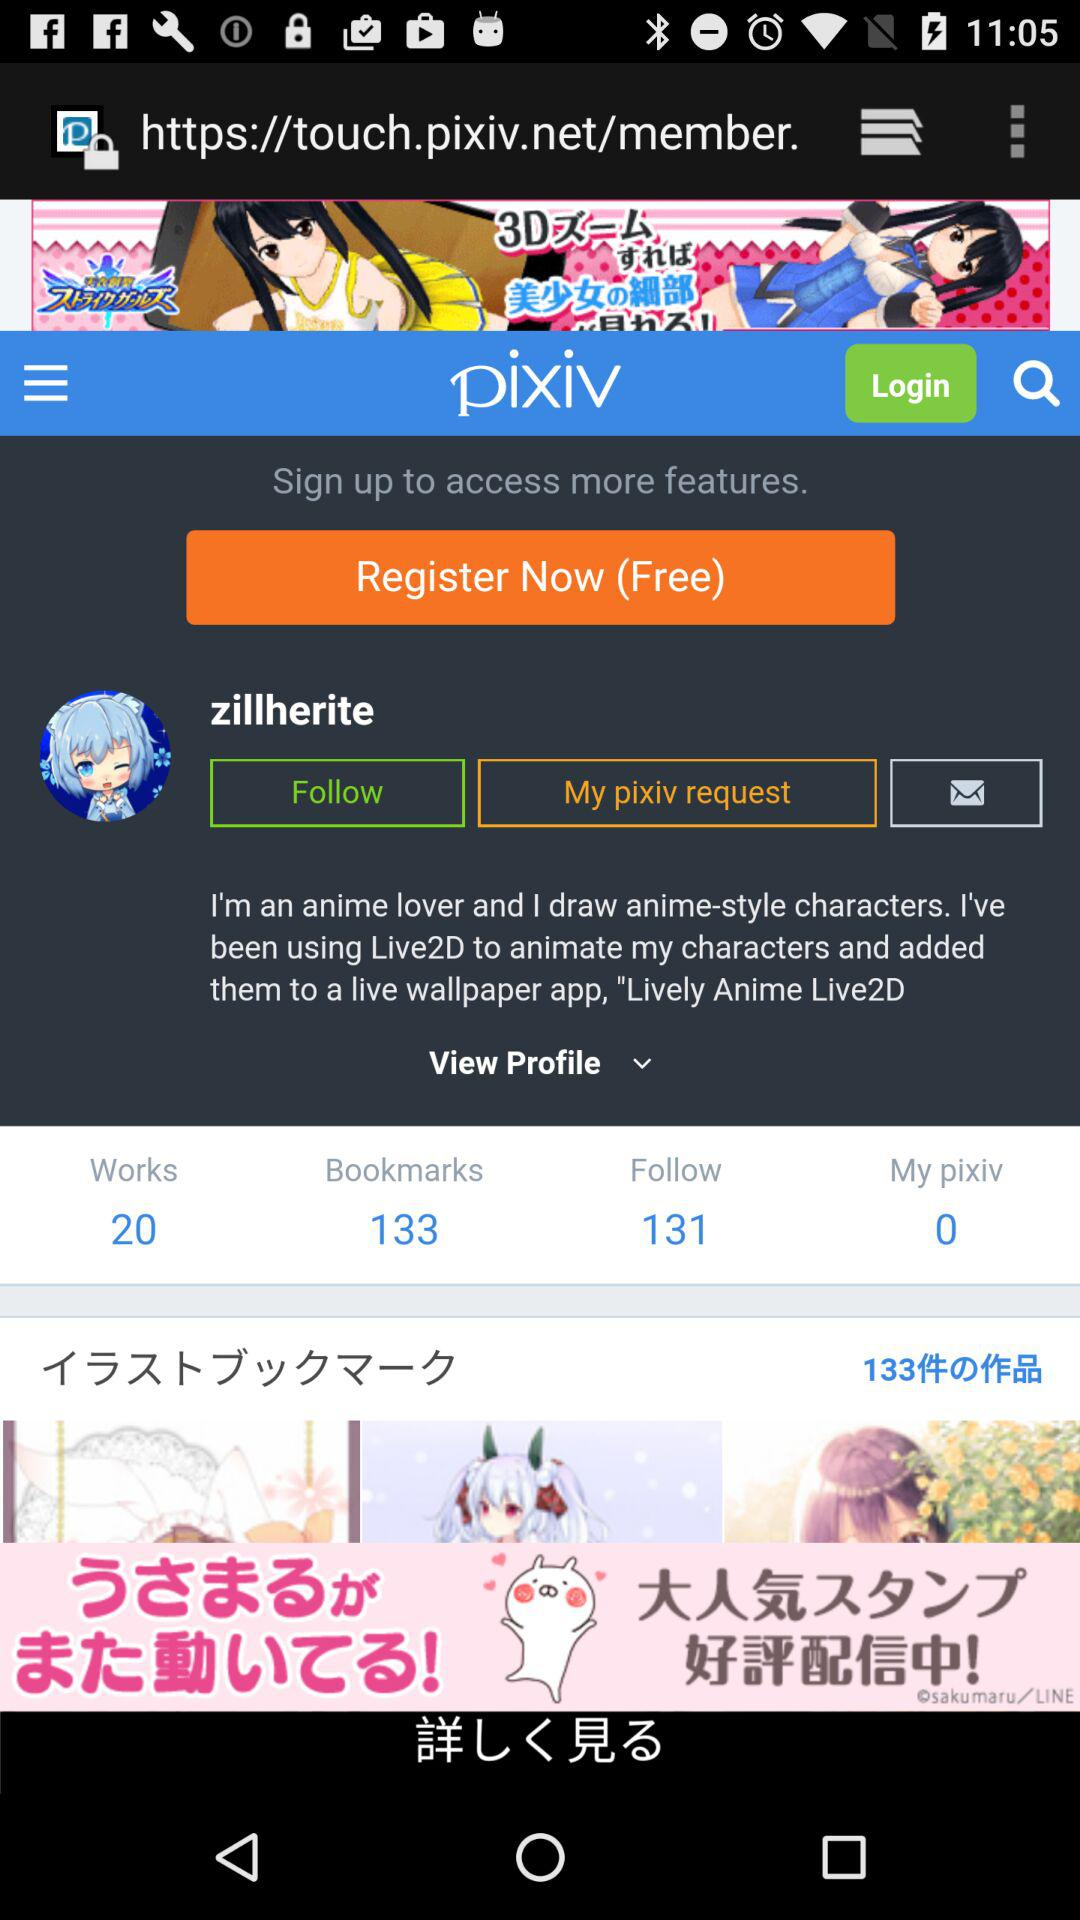What is the name of the user? The name of the user is Zillherite. 